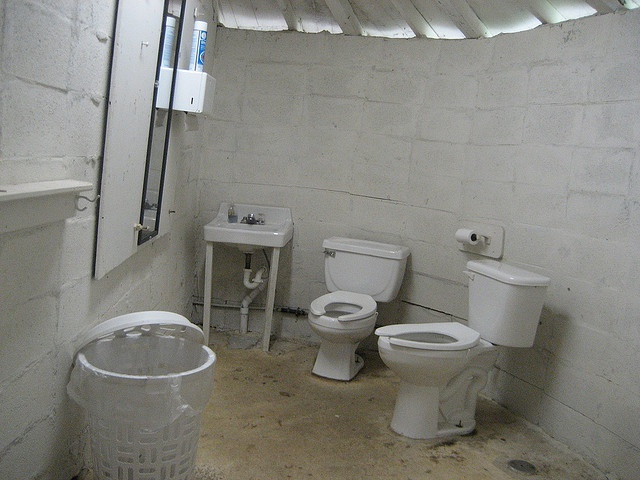Describe the objects in this image and their specific colors. I can see toilet in gray and darkgray tones, toilet in gray, darkgray, darkgreen, and black tones, and sink in gray tones in this image. 